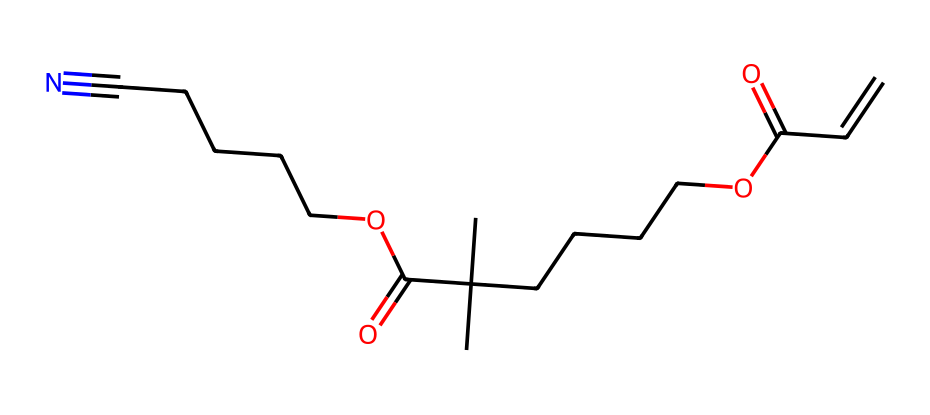What is the total number of carbon atoms in this chemical? To count the carbon atoms, we look at the SMILES representation. The "C" represents carbon atoms, and we identify them throughout the structure. After counting, we find that there are 15 carbon atoms present.
Answer: 15 How many functional groups are present in this chemical? By examining the structure, we identify functional groups such as carboxylic acids (−COOH) and a nitrile group (−C#N). These feature prominently in the chemical's structure. By analyzing the SMILES, we find there are three functional groups present.
Answer: 3 What type of bond connects the carbon atoms in this molecule? In the SMILES, most carbon atoms are connected by single bonds, indicated by the absence of numbers and symbols. However, the presence of "C#N" suggests a triple bond between carbon and nitrogen. In summary, the primary bond types between carbon atoms are single bonds, with one triple bond to nitrogen.
Answer: single and triple bonds What type of polymer does this chemical structure suggest? The presence of repeating units and functional groups, especially those conducive to polymerization, points towards the formation of polyesters or polyamides. These are common in fibers used for conductive materials in wearable tech.
Answer: polyester or polyamide How does the presence of the nitrile group affect the conductivity of this fiber? The nitrile group (−C#N) typically contributes to enhanced conductivity due to its electronegative nature and ability to participate in delocalized electron systems. Additionally, the presence of functional groups can interact with other materials in composites for improved electrical characteristics.
Answer: enhances conductivity 